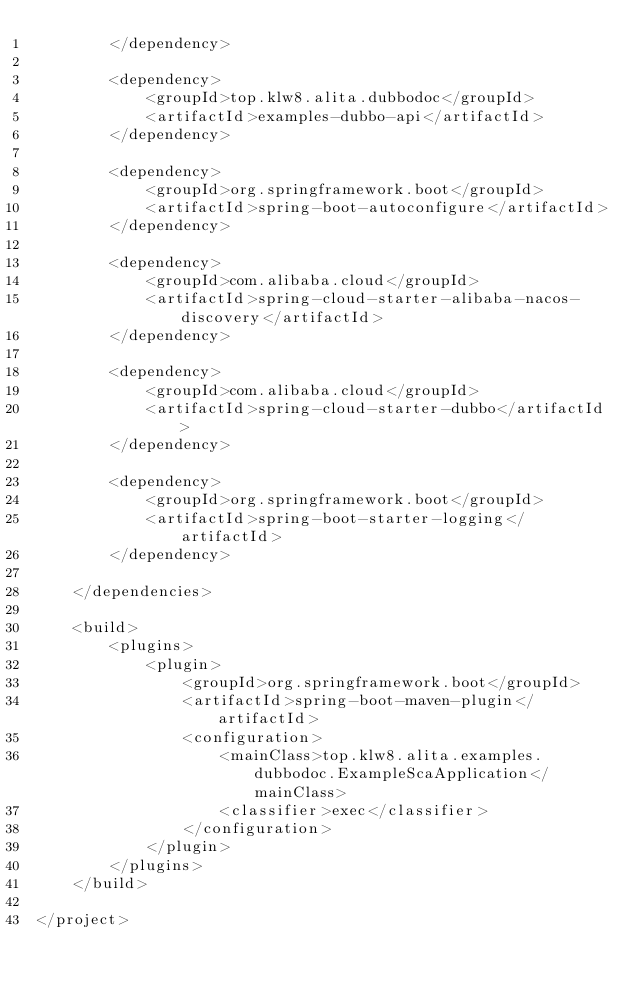Convert code to text. <code><loc_0><loc_0><loc_500><loc_500><_XML_>        </dependency>

        <dependency>
            <groupId>top.klw8.alita.dubbodoc</groupId>
            <artifactId>examples-dubbo-api</artifactId>
        </dependency>

        <dependency>
            <groupId>org.springframework.boot</groupId>
            <artifactId>spring-boot-autoconfigure</artifactId>
        </dependency>

        <dependency>
            <groupId>com.alibaba.cloud</groupId>
            <artifactId>spring-cloud-starter-alibaba-nacos-discovery</artifactId>
        </dependency>

        <dependency>
            <groupId>com.alibaba.cloud</groupId>
            <artifactId>spring-cloud-starter-dubbo</artifactId>
        </dependency>

        <dependency>
            <groupId>org.springframework.boot</groupId>
            <artifactId>spring-boot-starter-logging</artifactId>
        </dependency>

    </dependencies>

    <build>
        <plugins>
            <plugin>
                <groupId>org.springframework.boot</groupId>
                <artifactId>spring-boot-maven-plugin</artifactId>
                <configuration>
                    <mainClass>top.klw8.alita.examples.dubbodoc.ExampleScaApplication</mainClass>
                    <classifier>exec</classifier>
                </configuration>
            </plugin>
        </plugins>
    </build>

</project></code> 